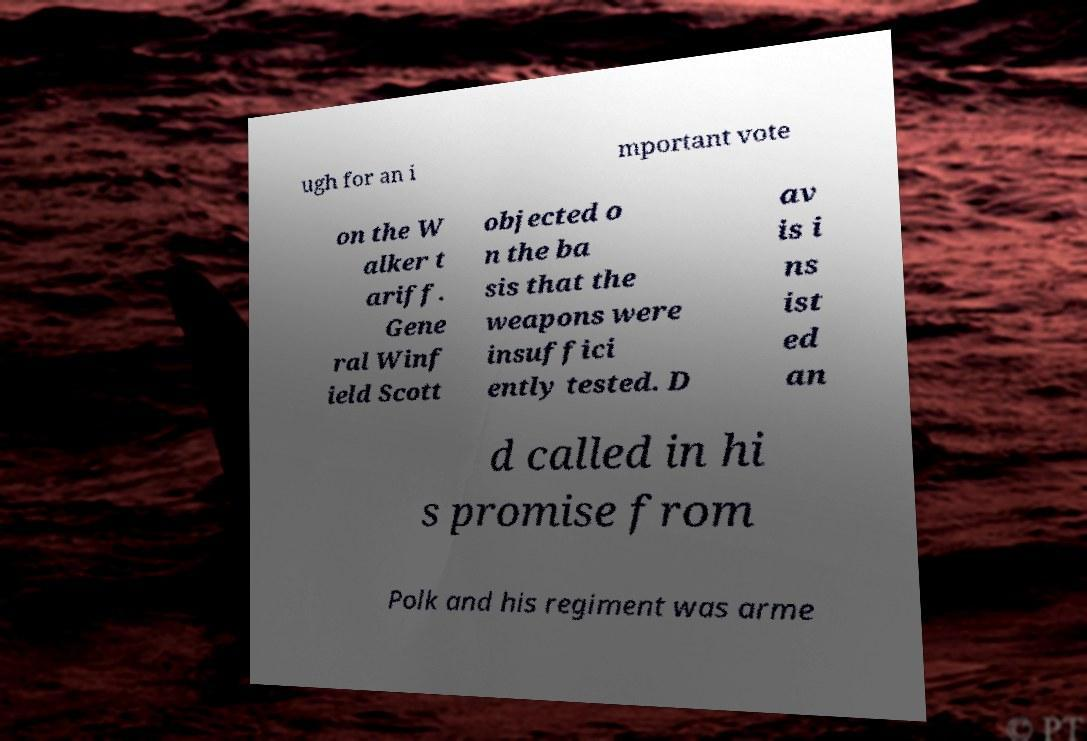Could you assist in decoding the text presented in this image and type it out clearly? ugh for an i mportant vote on the W alker t ariff. Gene ral Winf ield Scott objected o n the ba sis that the weapons were insuffici ently tested. D av is i ns ist ed an d called in hi s promise from Polk and his regiment was arme 